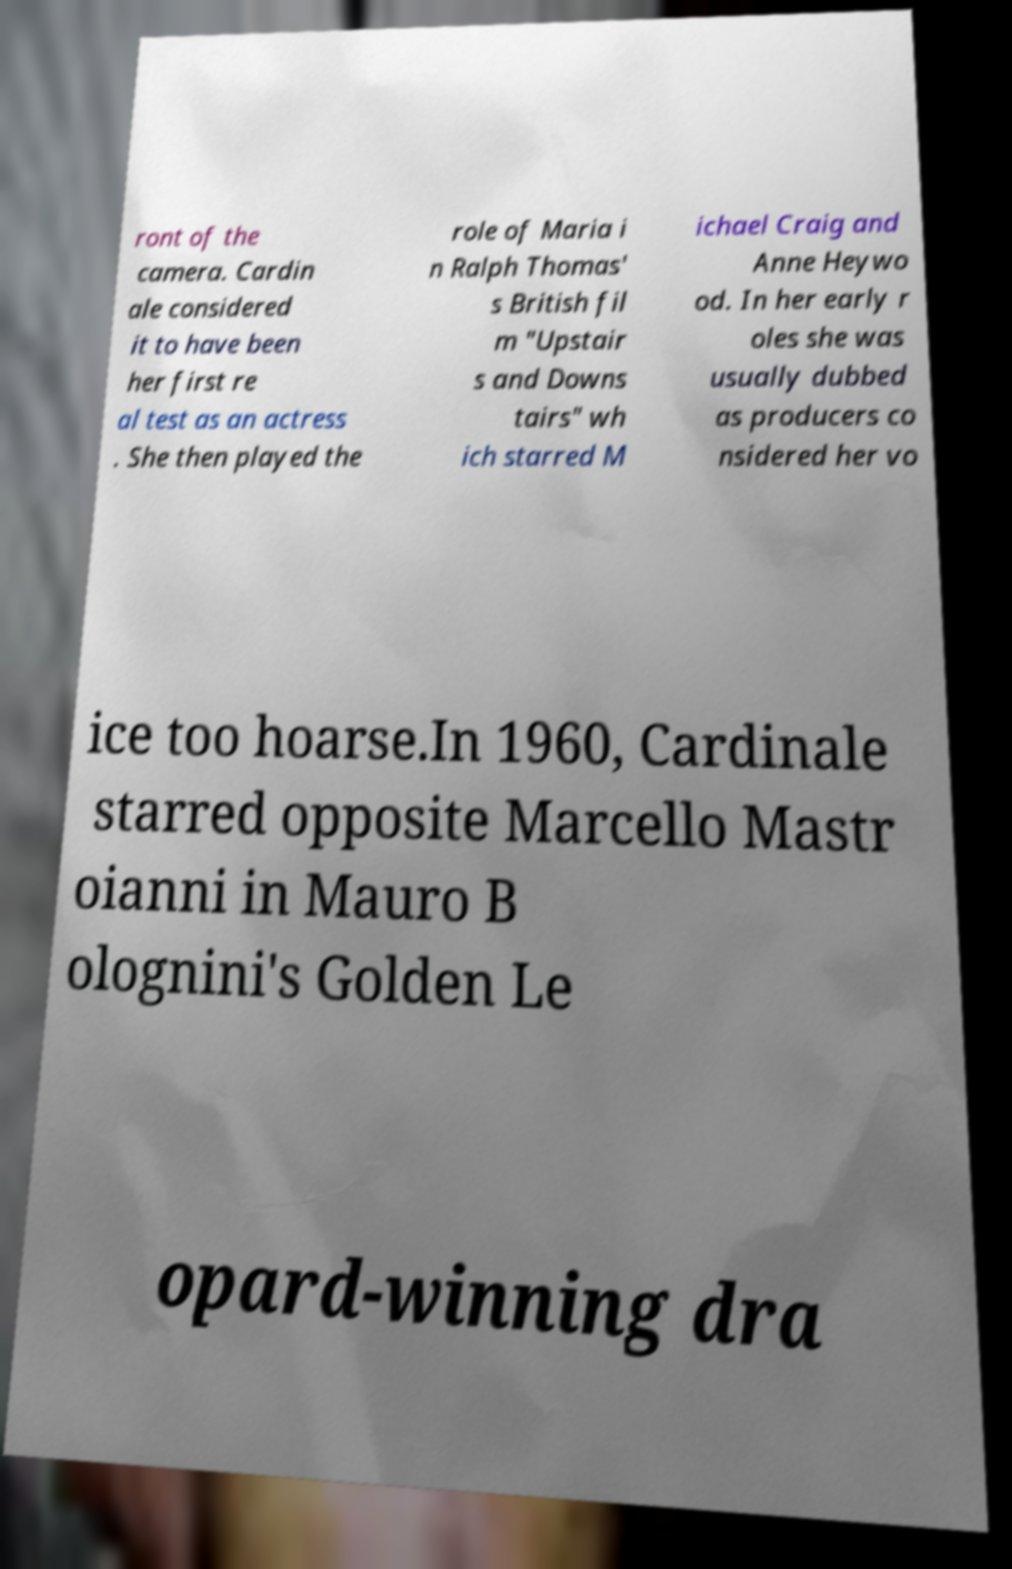Please read and relay the text visible in this image. What does it say? ront of the camera. Cardin ale considered it to have been her first re al test as an actress . She then played the role of Maria i n Ralph Thomas' s British fil m "Upstair s and Downs tairs" wh ich starred M ichael Craig and Anne Heywo od. In her early r oles she was usually dubbed as producers co nsidered her vo ice too hoarse.In 1960, Cardinale starred opposite Marcello Mastr oianni in Mauro B olognini's Golden Le opard-winning dra 